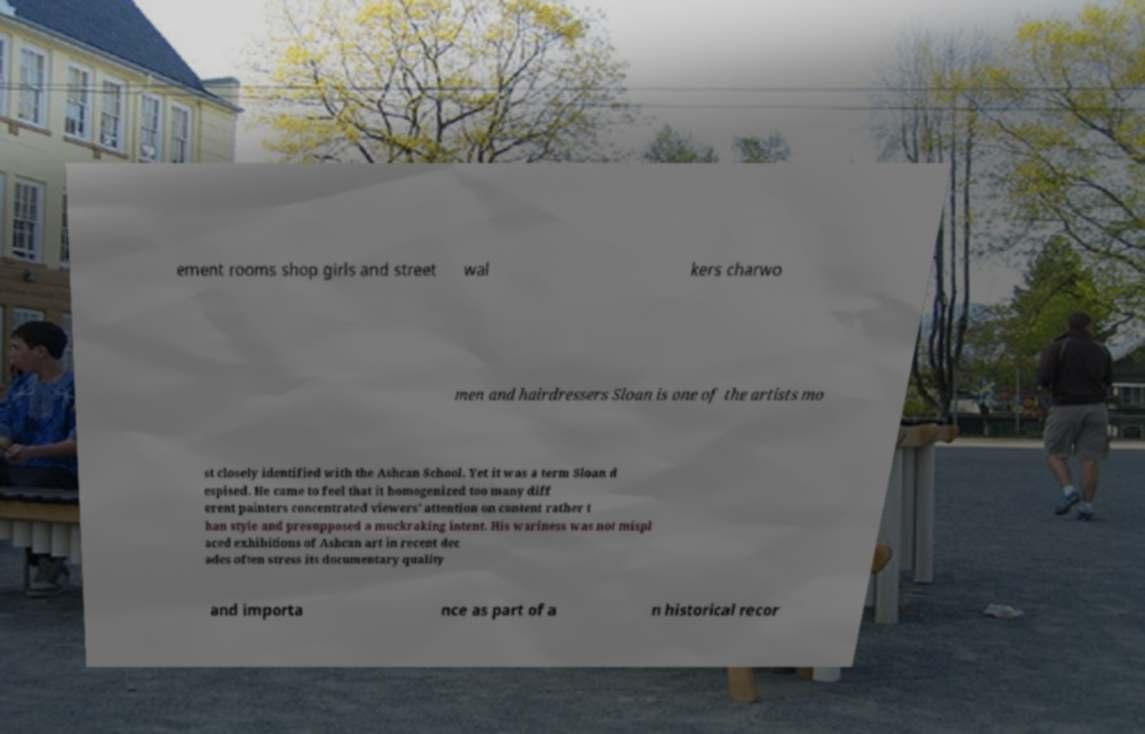For documentation purposes, I need the text within this image transcribed. Could you provide that? ement rooms shop girls and street wal kers charwo men and hairdressers Sloan is one of the artists mo st closely identified with the Ashcan School. Yet it was a term Sloan d espised. He came to feel that it homogenized too many diff erent painters concentrated viewers' attention on content rather t han style and presupposed a muckraking intent. His wariness was not mispl aced exhibitions of Ashcan art in recent dec ades often stress its documentary quality and importa nce as part of a n historical recor 